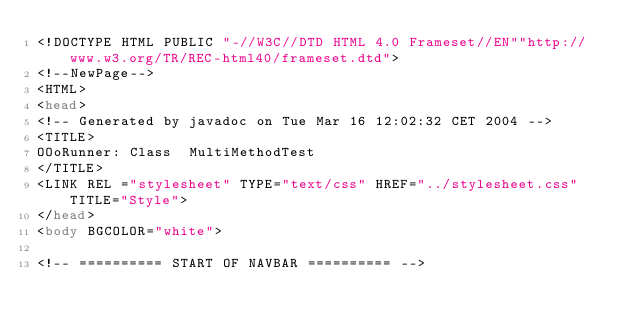Convert code to text. <code><loc_0><loc_0><loc_500><loc_500><_HTML_><!DOCTYPE HTML PUBLIC "-//W3C//DTD HTML 4.0 Frameset//EN""http://www.w3.org/TR/REC-html40/frameset.dtd">
<!--NewPage-->
<HTML>
<head>
<!-- Generated by javadoc on Tue Mar 16 12:02:32 CET 2004 -->
<TITLE>
OOoRunner: Class  MultiMethodTest
</TITLE>
<LINK REL ="stylesheet" TYPE="text/css" HREF="../stylesheet.css" TITLE="Style">
</head>
<body BGCOLOR="white">

<!-- ========== START OF NAVBAR ========== --></code> 